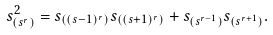<formula> <loc_0><loc_0><loc_500><loc_500>s _ { ( s ^ { r } ) } ^ { 2 } = s _ { ( ( s - 1 ) ^ { r } ) } s _ { ( ( s + 1 ) ^ { r } ) } + s _ { ( s ^ { r - 1 } ) } s _ { ( s ^ { r + 1 } ) } .</formula> 